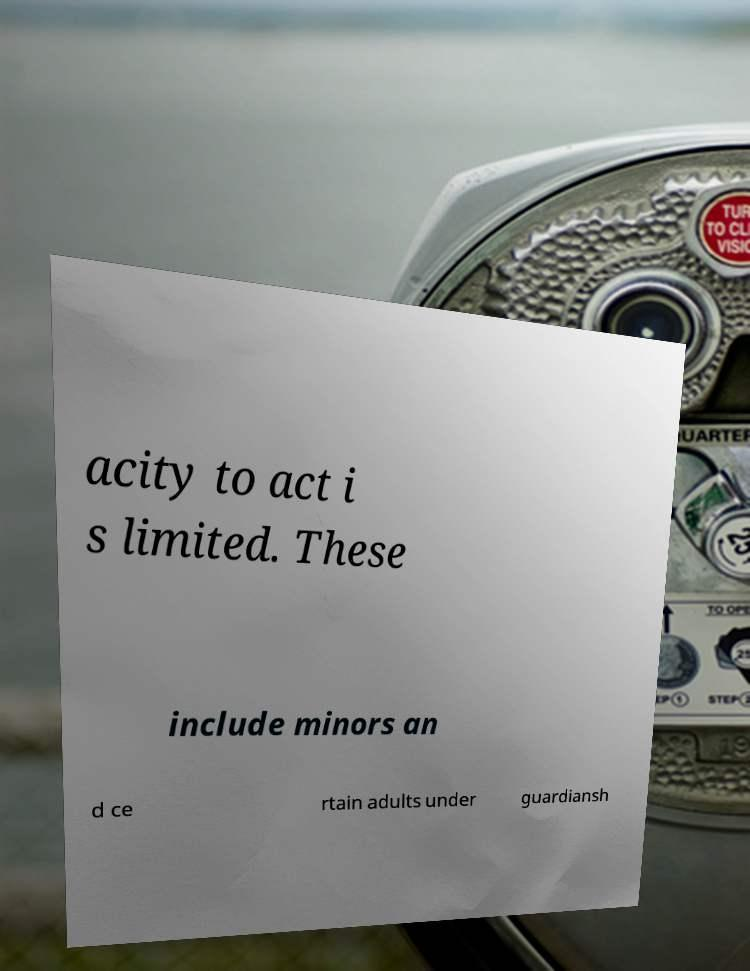I need the written content from this picture converted into text. Can you do that? acity to act i s limited. These include minors an d ce rtain adults under guardiansh 